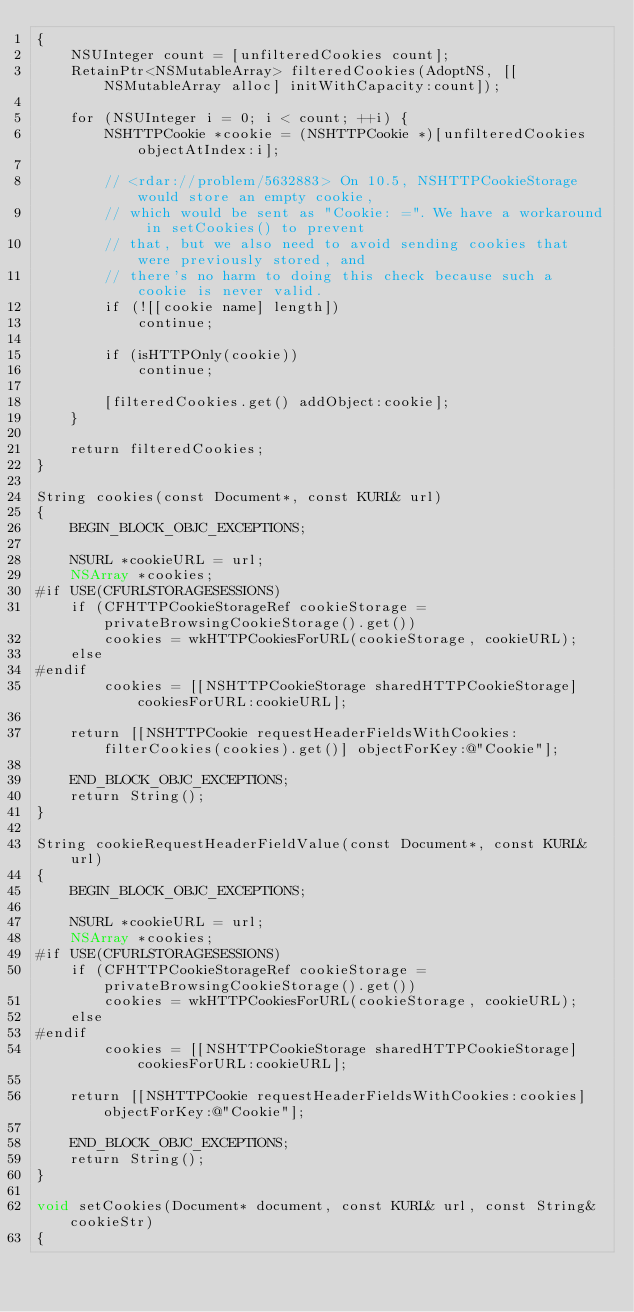Convert code to text. <code><loc_0><loc_0><loc_500><loc_500><_ObjectiveC_>{
    NSUInteger count = [unfilteredCookies count];
    RetainPtr<NSMutableArray> filteredCookies(AdoptNS, [[NSMutableArray alloc] initWithCapacity:count]);

    for (NSUInteger i = 0; i < count; ++i) {
        NSHTTPCookie *cookie = (NSHTTPCookie *)[unfilteredCookies objectAtIndex:i];

        // <rdar://problem/5632883> On 10.5, NSHTTPCookieStorage would store an empty cookie,
        // which would be sent as "Cookie: =". We have a workaround in setCookies() to prevent
        // that, but we also need to avoid sending cookies that were previously stored, and
        // there's no harm to doing this check because such a cookie is never valid.
        if (![[cookie name] length])
            continue;

        if (isHTTPOnly(cookie))
            continue;

        [filteredCookies.get() addObject:cookie];
    }

    return filteredCookies;
}

String cookies(const Document*, const KURL& url)
{
    BEGIN_BLOCK_OBJC_EXCEPTIONS;

    NSURL *cookieURL = url;
    NSArray *cookies;
#if USE(CFURLSTORAGESESSIONS)
    if (CFHTTPCookieStorageRef cookieStorage = privateBrowsingCookieStorage().get())
        cookies = wkHTTPCookiesForURL(cookieStorage, cookieURL);
    else
#endif
        cookies = [[NSHTTPCookieStorage sharedHTTPCookieStorage] cookiesForURL:cookieURL];

    return [[NSHTTPCookie requestHeaderFieldsWithCookies:filterCookies(cookies).get()] objectForKey:@"Cookie"];

    END_BLOCK_OBJC_EXCEPTIONS;
    return String();
}

String cookieRequestHeaderFieldValue(const Document*, const KURL& url)
{
    BEGIN_BLOCK_OBJC_EXCEPTIONS;

    NSURL *cookieURL = url;
    NSArray *cookies;
#if USE(CFURLSTORAGESESSIONS)
    if (CFHTTPCookieStorageRef cookieStorage = privateBrowsingCookieStorage().get())
        cookies = wkHTTPCookiesForURL(cookieStorage, cookieURL);
    else
#endif
        cookies = [[NSHTTPCookieStorage sharedHTTPCookieStorage] cookiesForURL:cookieURL];

    return [[NSHTTPCookie requestHeaderFieldsWithCookies:cookies] objectForKey:@"Cookie"];

    END_BLOCK_OBJC_EXCEPTIONS;
    return String();
}

void setCookies(Document* document, const KURL& url, const String& cookieStr)
{</code> 